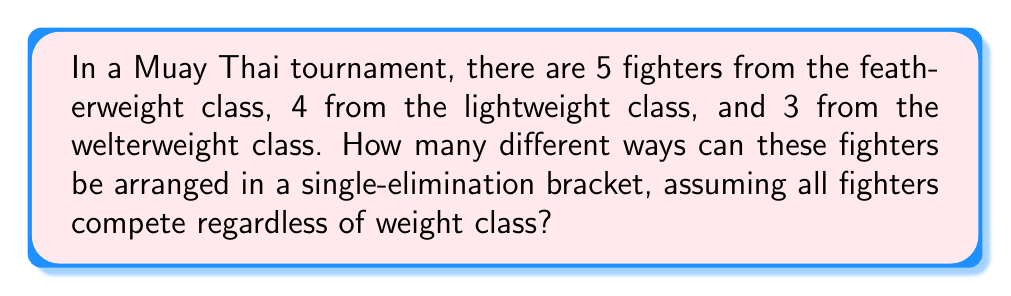Solve this math problem. Let's approach this step-by-step:

1) First, we need to understand that this is a permutation problem. We're arranging all the fighters in a line, which is equivalent to filling out a bracket.

2) The total number of fighters is 5 + 4 + 3 = 12.

3) If all fighters were indistinguishable, we would simply calculate 12!, but we need to account for the fact that fighters within each weight class are considered indistinguishable for the purposes of this problem.

4) When we have indistinguishable objects within a larger set of distinguishable objects, we use the concept of multinomial coefficients.

5) The formula for multinomial coefficients is:

   $${n \choose n_1, n_2, ..., n_k} = \frac{n!}{n_1! \cdot n_2! \cdot ... \cdot n_k!}$$

   Where $n$ is the total number of objects, and $n_1, n_2, ..., n_k$ are the numbers of each type of object.

6) In our case:
   $n = 12$ (total fighters)
   $n_1 = 5$ (featherweight)
   $n_2 = 4$ (lightweight)
   $n_3 = 3$ (welterweight)

7) Plugging these into our formula:

   $${12 \choose 5, 4, 3} = \frac{12!}{5! \cdot 4! \cdot 3!}$$

8) Calculating this:
   $$\frac{12!}{5! \cdot 4! \cdot 3!} = \frac{479,001,600}{120 \cdot 24 \cdot 6} = 27,720$$

Therefore, there are 27,720 different ways to arrange these fighters in the tournament bracket.
Answer: 27,720 